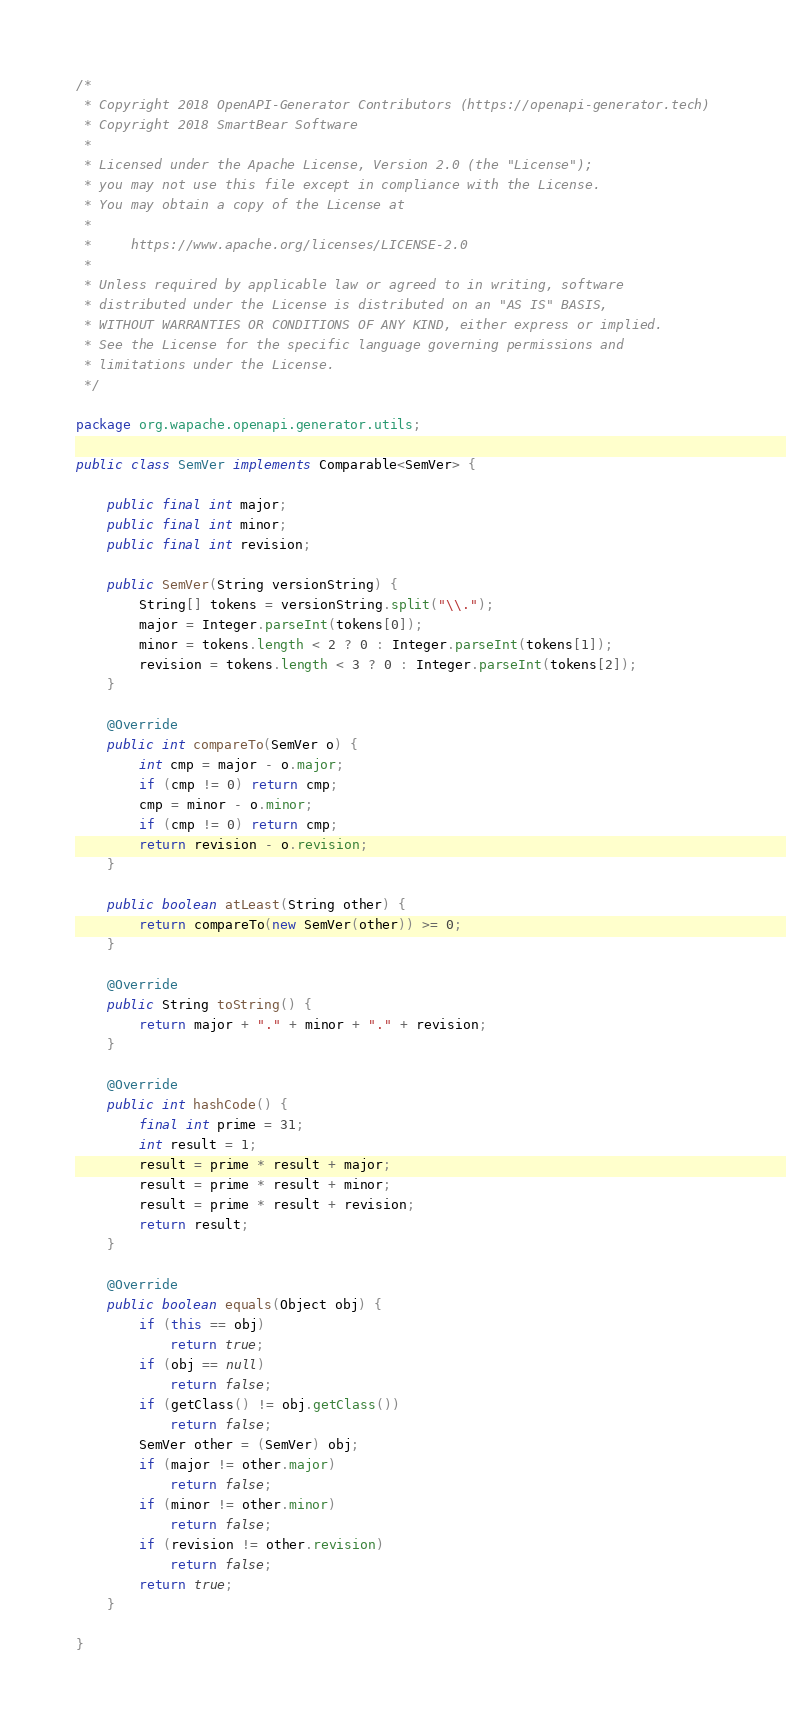<code> <loc_0><loc_0><loc_500><loc_500><_Java_>/*
 * Copyright 2018 OpenAPI-Generator Contributors (https://openapi-generator.tech)
 * Copyright 2018 SmartBear Software
 *
 * Licensed under the Apache License, Version 2.0 (the "License");
 * you may not use this file except in compliance with the License.
 * You may obtain a copy of the License at
 *
 *     https://www.apache.org/licenses/LICENSE-2.0
 *
 * Unless required by applicable law or agreed to in writing, software
 * distributed under the License is distributed on an "AS IS" BASIS,
 * WITHOUT WARRANTIES OR CONDITIONS OF ANY KIND, either express or implied.
 * See the License for the specific language governing permissions and
 * limitations under the License.
 */

package org.wapache.openapi.generator.utils;

public class SemVer implements Comparable<SemVer> {

    public final int major;
    public final int minor;
    public final int revision;

    public SemVer(String versionString) {
        String[] tokens = versionString.split("\\.");
        major = Integer.parseInt(tokens[0]);
        minor = tokens.length < 2 ? 0 : Integer.parseInt(tokens[1]);
        revision = tokens.length < 3 ? 0 : Integer.parseInt(tokens[2]);
    }

    @Override
    public int compareTo(SemVer o) {
        int cmp = major - o.major;
        if (cmp != 0) return cmp;
        cmp = minor - o.minor;
        if (cmp != 0) return cmp;
        return revision - o.revision;
    }

    public boolean atLeast(String other) {
        return compareTo(new SemVer(other)) >= 0;
    }

    @Override
    public String toString() {
        return major + "." + minor + "." + revision;
    }

    @Override
    public int hashCode() {
        final int prime = 31;
        int result = 1;
        result = prime * result + major;
        result = prime * result + minor;
        result = prime * result + revision;
        return result;
    }

    @Override
    public boolean equals(Object obj) {
        if (this == obj)
            return true;
        if (obj == null)
            return false;
        if (getClass() != obj.getClass())
            return false;
        SemVer other = (SemVer) obj;
        if (major != other.major)
            return false;
        if (minor != other.minor)
            return false;
        if (revision != other.revision)
            return false;
        return true;
    }

}</code> 